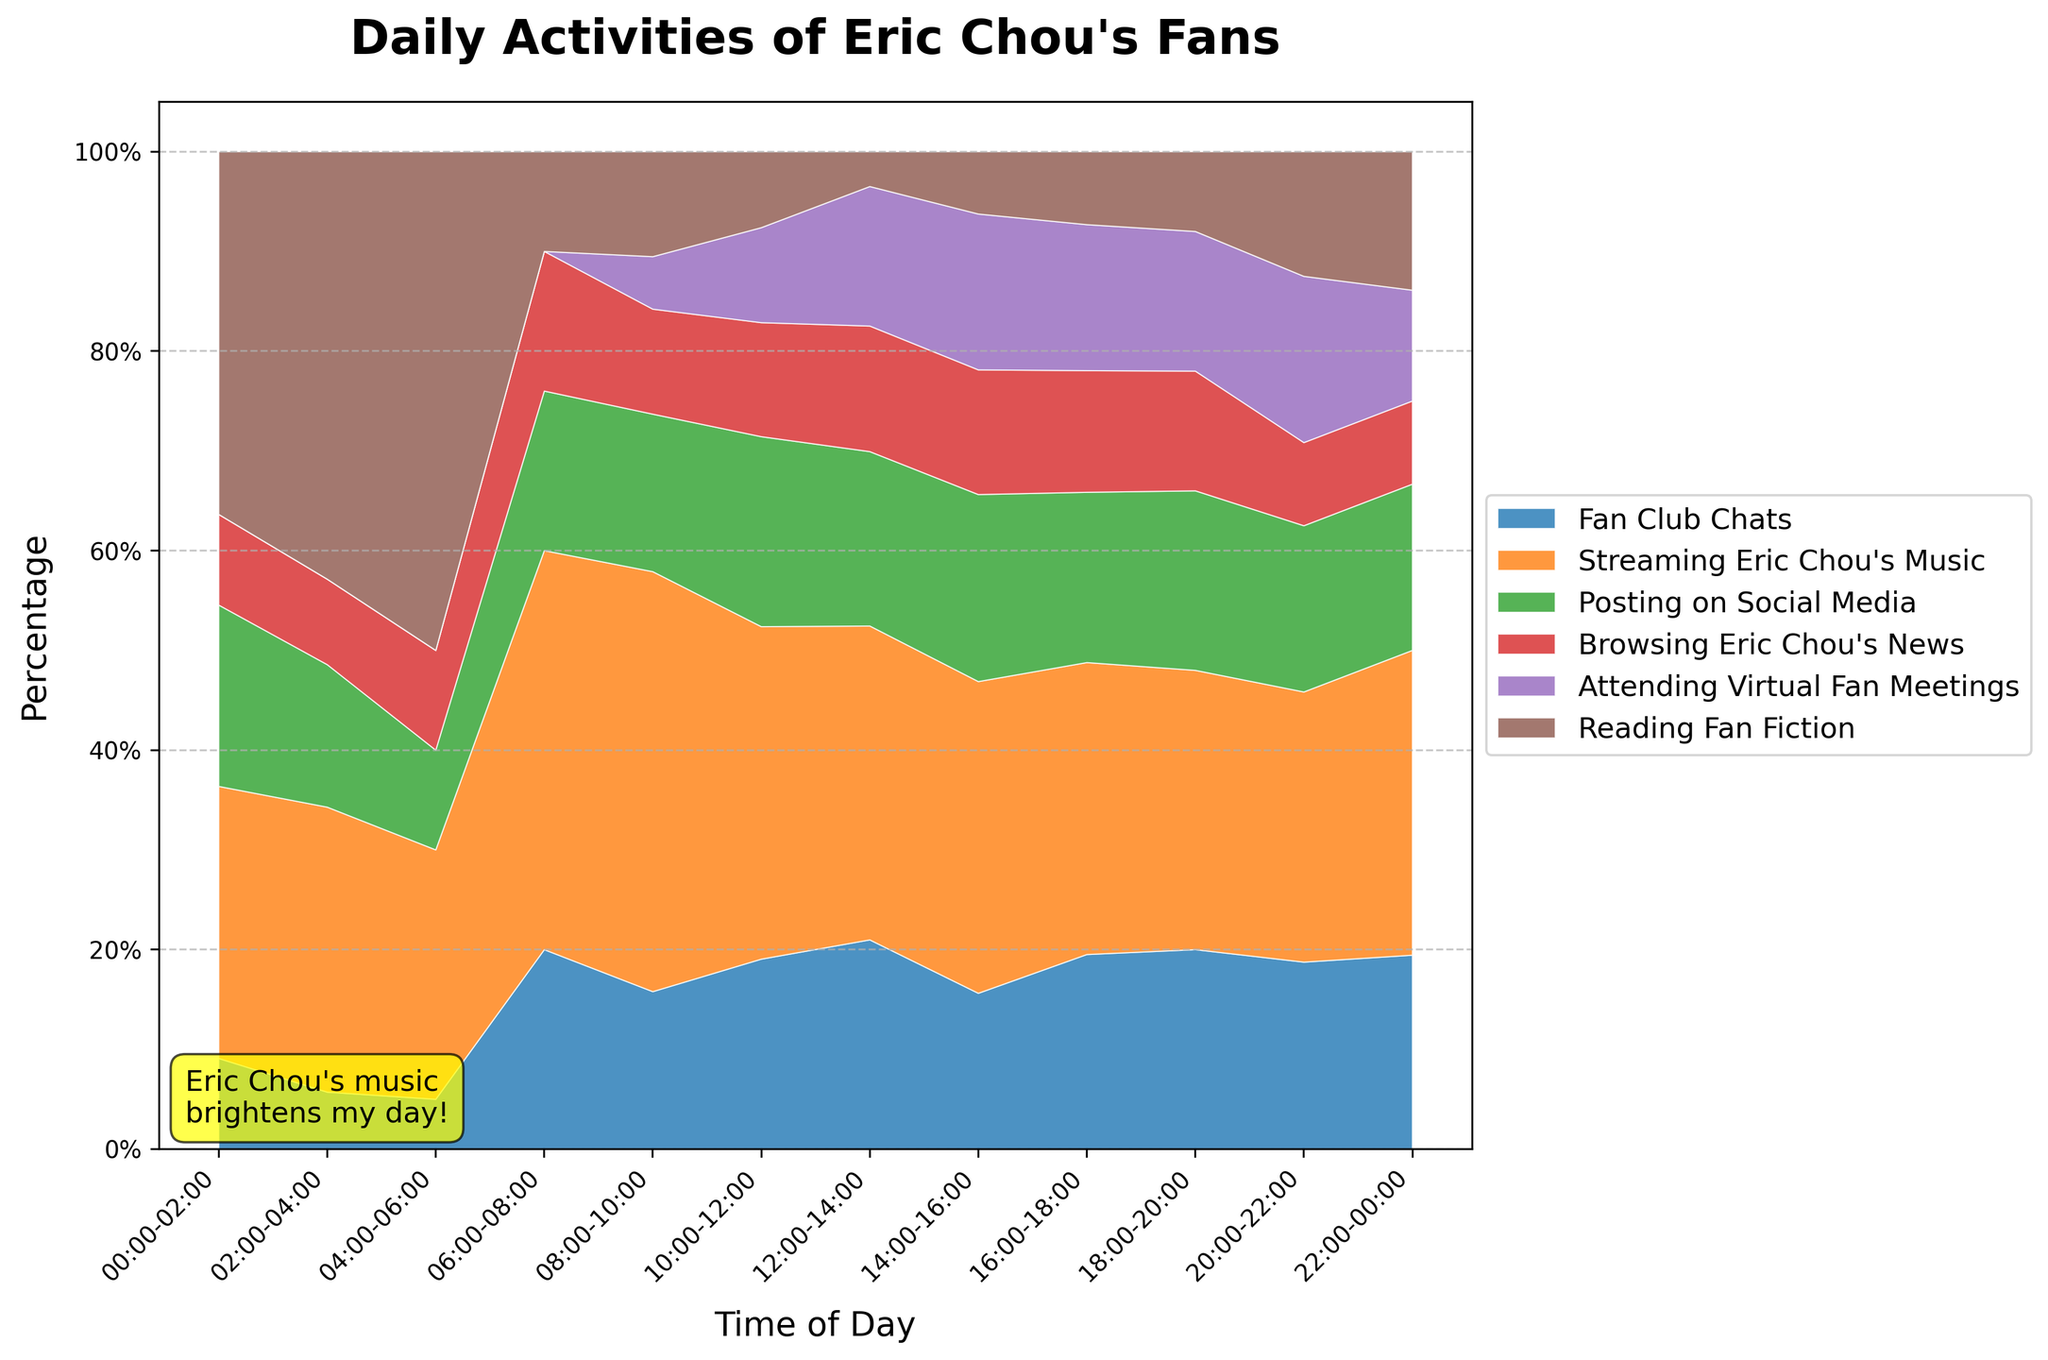what is the title of the chart? The chart title is located at the top of the figure and describes the content of the entire plot. In this case, the title reads "Daily Activities of Eric Chou's Fans".
Answer: Daily Activities of Eric Chou's Fans What time segment has the highest percentage for attending virtual fan meetings? Look at the section of the chart labeled "Attending Virtual Fan Meetings" and observe its size across all time segments. The largest section appears between 18:00 and 20:00.
Answer: 18:00-20:00 Which activity has the lowest percentage consistently throughout the day? Observe the smallest segment for each time of day in the stacked area chart. "Reading Fan Fiction" consistently has the lowest percentage throughout the day.
Answer: Reading Fan Fiction During which time period does streaming Eric Chou's music peak? Look at the segment color-coded for streaming Eric Chou's music and check when it reaches its maximum area. The peak occurs between 18:00 and 20:00.
Answer: 18:00-20:00 Compare the percentage of browsing Eric Chou's news and posting on social media between 08:00-10:00. Which one is higher? Compare the sections for "Browsing Eric Chou's News" and "Posting on Social Media" in the time segment 08:00-10:00. Posting on social media is larger than browsing Eric Chou's news.
Answer: Posting on Social Media What is the total percentage occupied by fan club chats, streaming Eric Chou's music, and attending virtual fan meetings at 10:00-12:00? Sum the percentages for "Fan Club Chats", "Streaming Eric Chou's Music", and "Attending Virtual Fan Meetings" at the 10:00-12:00 time segment. 20% + 35% + 10% = 65%.
Answer: 65% Which activity sees a significant increase in the evening time, especially from 18:00-20:00? Identify the activity that has a small segment in the morning but grows significantly in the evening. "Attending Virtual Fan Meetings" increases significantly from 18:00-20:00.
Answer: Attending Virtual Fan Meetings When do Eric Chou's fans read fan fiction the most? Look for the time segment with the highest value for the "Reading Fan Fiction" section. This occurs between 20:00 and 22:00.
Answer: 20:00-22:00 Between 00:00-02:00 and 02:00-04:00, which activity shows the biggest decrease in percentage? Compare the activities between the two time segments and observe the percentage drop for each. "Streaming Eric Chou's Music" drops from 15% to 10%, a decrease of 5%, which is the largest among all activities.
Answer: Streaming Eric Chou's Music 